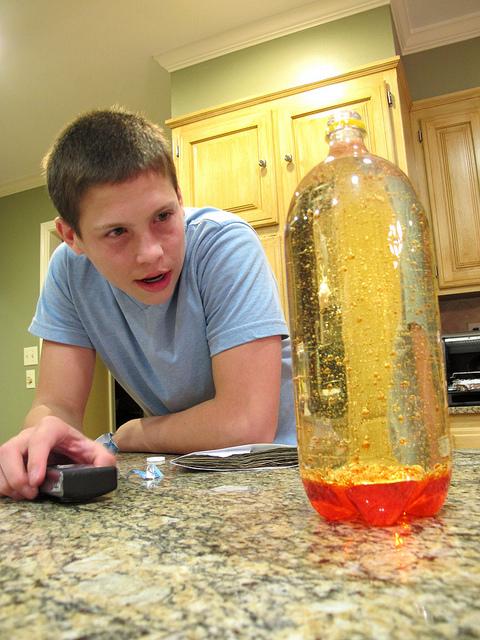Could that be soda in the bottle?
Be succinct. Yes. What color is the boy's shirt?
Concise answer only. Blue. Is he doing a science experiment?
Answer briefly. Yes. 